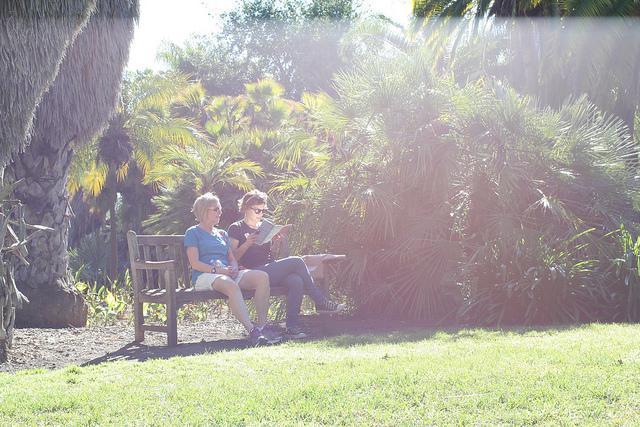How many people are reading in the photo?
Give a very brief answer. 1. How many people are there?
Give a very brief answer. 2. How many people are wearing an orange shirt?
Give a very brief answer. 0. 